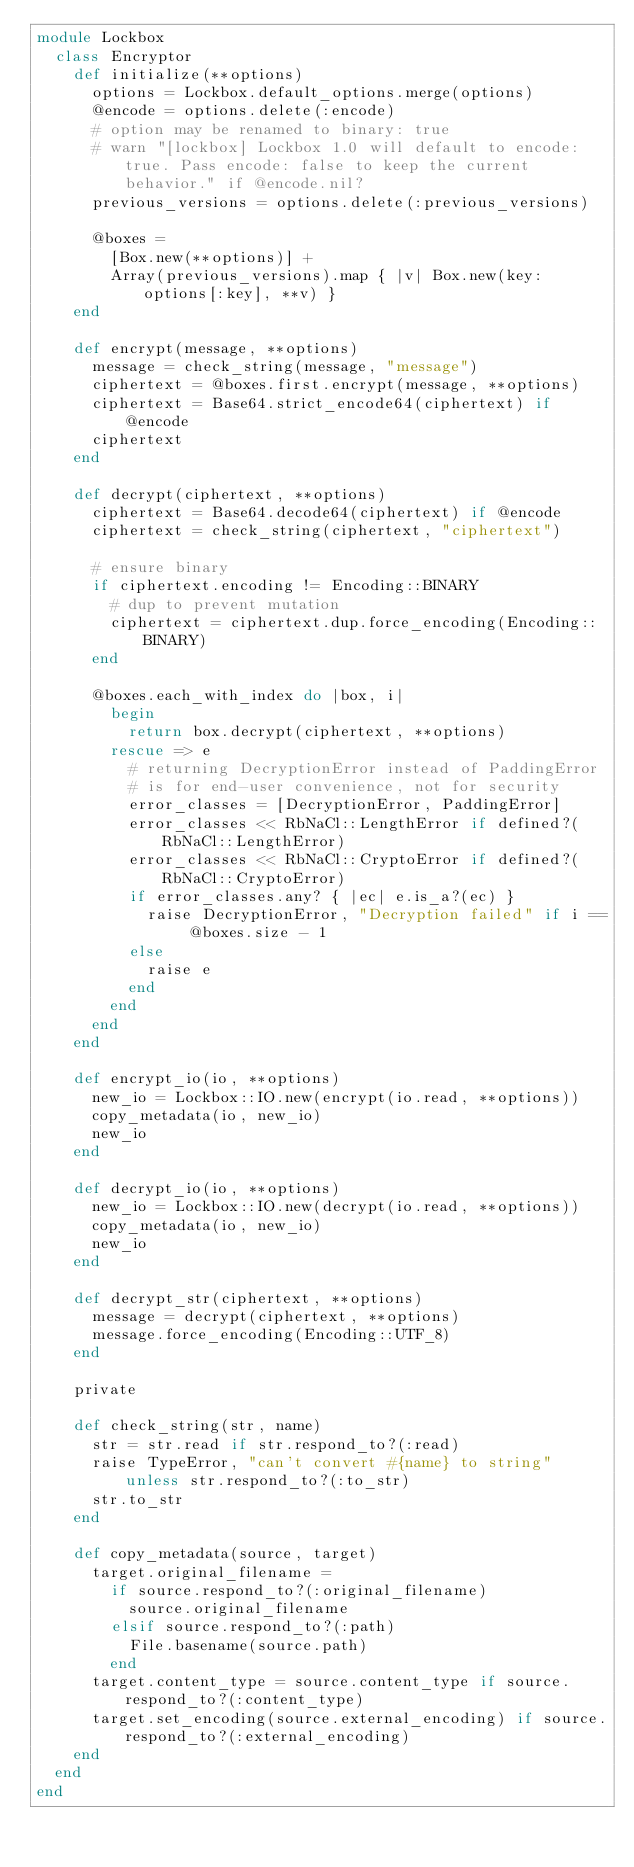Convert code to text. <code><loc_0><loc_0><loc_500><loc_500><_Ruby_>module Lockbox
  class Encryptor
    def initialize(**options)
      options = Lockbox.default_options.merge(options)
      @encode = options.delete(:encode)
      # option may be renamed to binary: true
      # warn "[lockbox] Lockbox 1.0 will default to encode: true. Pass encode: false to keep the current behavior." if @encode.nil?
      previous_versions = options.delete(:previous_versions)

      @boxes =
        [Box.new(**options)] +
        Array(previous_versions).map { |v| Box.new(key: options[:key], **v) }
    end

    def encrypt(message, **options)
      message = check_string(message, "message")
      ciphertext = @boxes.first.encrypt(message, **options)
      ciphertext = Base64.strict_encode64(ciphertext) if @encode
      ciphertext
    end

    def decrypt(ciphertext, **options)
      ciphertext = Base64.decode64(ciphertext) if @encode
      ciphertext = check_string(ciphertext, "ciphertext")

      # ensure binary
      if ciphertext.encoding != Encoding::BINARY
        # dup to prevent mutation
        ciphertext = ciphertext.dup.force_encoding(Encoding::BINARY)
      end

      @boxes.each_with_index do |box, i|
        begin
          return box.decrypt(ciphertext, **options)
        rescue => e
          # returning DecryptionError instead of PaddingError
          # is for end-user convenience, not for security
          error_classes = [DecryptionError, PaddingError]
          error_classes << RbNaCl::LengthError if defined?(RbNaCl::LengthError)
          error_classes << RbNaCl::CryptoError if defined?(RbNaCl::CryptoError)
          if error_classes.any? { |ec| e.is_a?(ec) }
            raise DecryptionError, "Decryption failed" if i == @boxes.size - 1
          else
            raise e
          end
        end
      end
    end

    def encrypt_io(io, **options)
      new_io = Lockbox::IO.new(encrypt(io.read, **options))
      copy_metadata(io, new_io)
      new_io
    end

    def decrypt_io(io, **options)
      new_io = Lockbox::IO.new(decrypt(io.read, **options))
      copy_metadata(io, new_io)
      new_io
    end

    def decrypt_str(ciphertext, **options)
      message = decrypt(ciphertext, **options)
      message.force_encoding(Encoding::UTF_8)
    end

    private

    def check_string(str, name)
      str = str.read if str.respond_to?(:read)
      raise TypeError, "can't convert #{name} to string" unless str.respond_to?(:to_str)
      str.to_str
    end

    def copy_metadata(source, target)
      target.original_filename =
        if source.respond_to?(:original_filename)
          source.original_filename
        elsif source.respond_to?(:path)
          File.basename(source.path)
        end
      target.content_type = source.content_type if source.respond_to?(:content_type)
      target.set_encoding(source.external_encoding) if source.respond_to?(:external_encoding)
    end
  end
end
</code> 